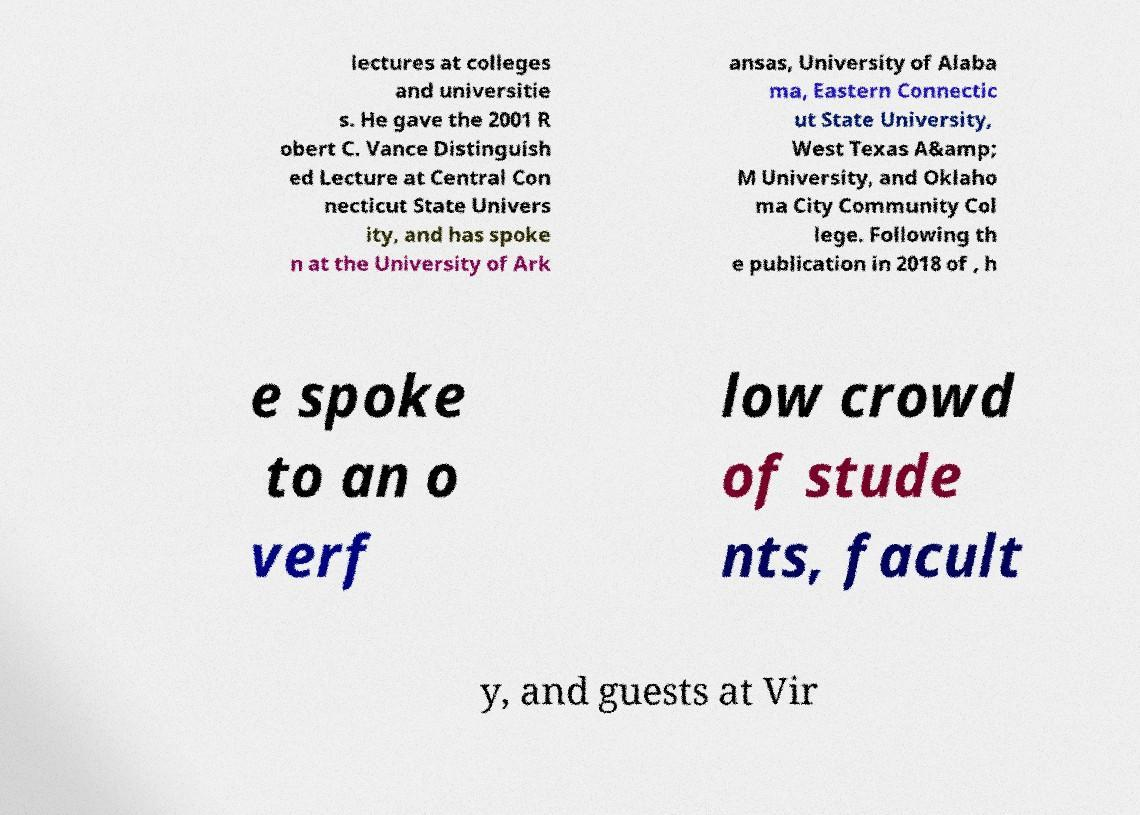Please identify and transcribe the text found in this image. lectures at colleges and universitie s. He gave the 2001 R obert C. Vance Distinguish ed Lecture at Central Con necticut State Univers ity, and has spoke n at the University of Ark ansas, University of Alaba ma, Eastern Connectic ut State University, West Texas A&amp; M University, and Oklaho ma City Community Col lege. Following th e publication in 2018 of , h e spoke to an o verf low crowd of stude nts, facult y, and guests at Vir 